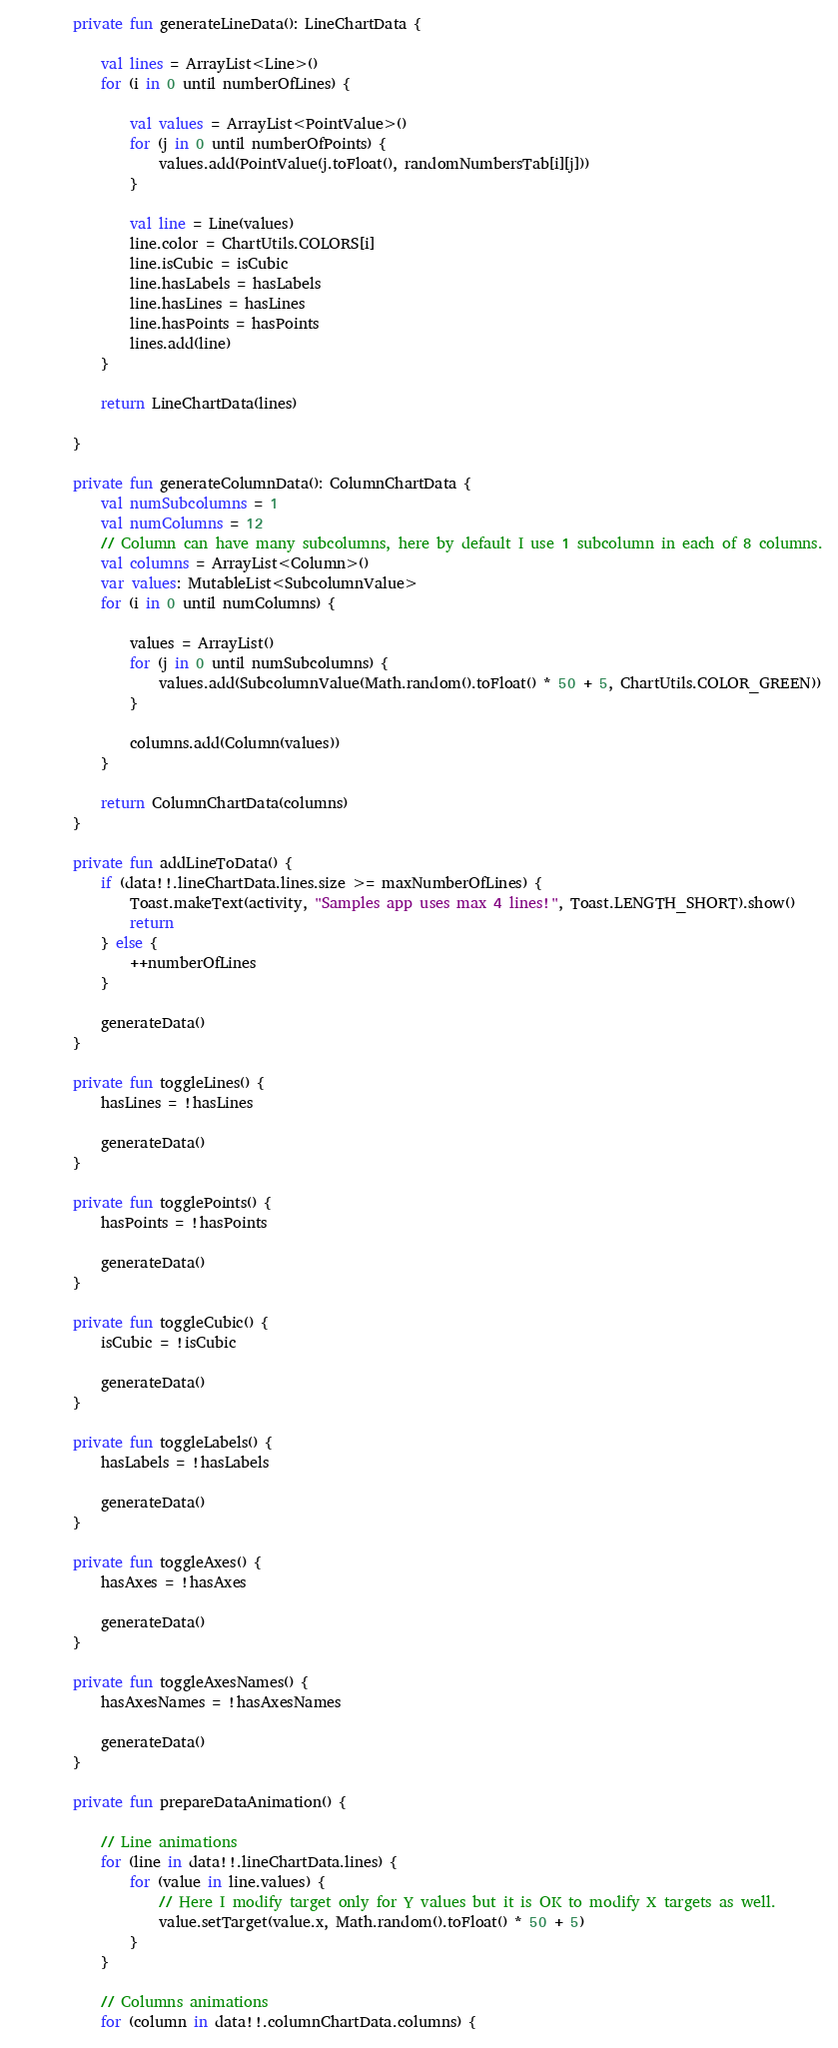Convert code to text. <code><loc_0><loc_0><loc_500><loc_500><_Kotlin_>
        private fun generateLineData(): LineChartData {

            val lines = ArrayList<Line>()
            for (i in 0 until numberOfLines) {

                val values = ArrayList<PointValue>()
                for (j in 0 until numberOfPoints) {
                    values.add(PointValue(j.toFloat(), randomNumbersTab[i][j]))
                }

                val line = Line(values)
                line.color = ChartUtils.COLORS[i]
                line.isCubic = isCubic
                line.hasLabels = hasLabels
                line.hasLines = hasLines
                line.hasPoints = hasPoints
                lines.add(line)
            }

            return LineChartData(lines)

        }

        private fun generateColumnData(): ColumnChartData {
            val numSubcolumns = 1
            val numColumns = 12
            // Column can have many subcolumns, here by default I use 1 subcolumn in each of 8 columns.
            val columns = ArrayList<Column>()
            var values: MutableList<SubcolumnValue>
            for (i in 0 until numColumns) {

                values = ArrayList()
                for (j in 0 until numSubcolumns) {
                    values.add(SubcolumnValue(Math.random().toFloat() * 50 + 5, ChartUtils.COLOR_GREEN))
                }

                columns.add(Column(values))
            }

            return ColumnChartData(columns)
        }

        private fun addLineToData() {
            if (data!!.lineChartData.lines.size >= maxNumberOfLines) {
                Toast.makeText(activity, "Samples app uses max 4 lines!", Toast.LENGTH_SHORT).show()
                return
            } else {
                ++numberOfLines
            }

            generateData()
        }

        private fun toggleLines() {
            hasLines = !hasLines

            generateData()
        }

        private fun togglePoints() {
            hasPoints = !hasPoints

            generateData()
        }

        private fun toggleCubic() {
            isCubic = !isCubic

            generateData()
        }

        private fun toggleLabels() {
            hasLabels = !hasLabels

            generateData()
        }

        private fun toggleAxes() {
            hasAxes = !hasAxes

            generateData()
        }

        private fun toggleAxesNames() {
            hasAxesNames = !hasAxesNames

            generateData()
        }

        private fun prepareDataAnimation() {

            // Line animations
            for (line in data!!.lineChartData.lines) {
                for (value in line.values) {
                    // Here I modify target only for Y values but it is OK to modify X targets as well.
                    value.setTarget(value.x, Math.random().toFloat() * 50 + 5)
                }
            }

            // Columns animations
            for (column in data!!.columnChartData.columns) {</code> 